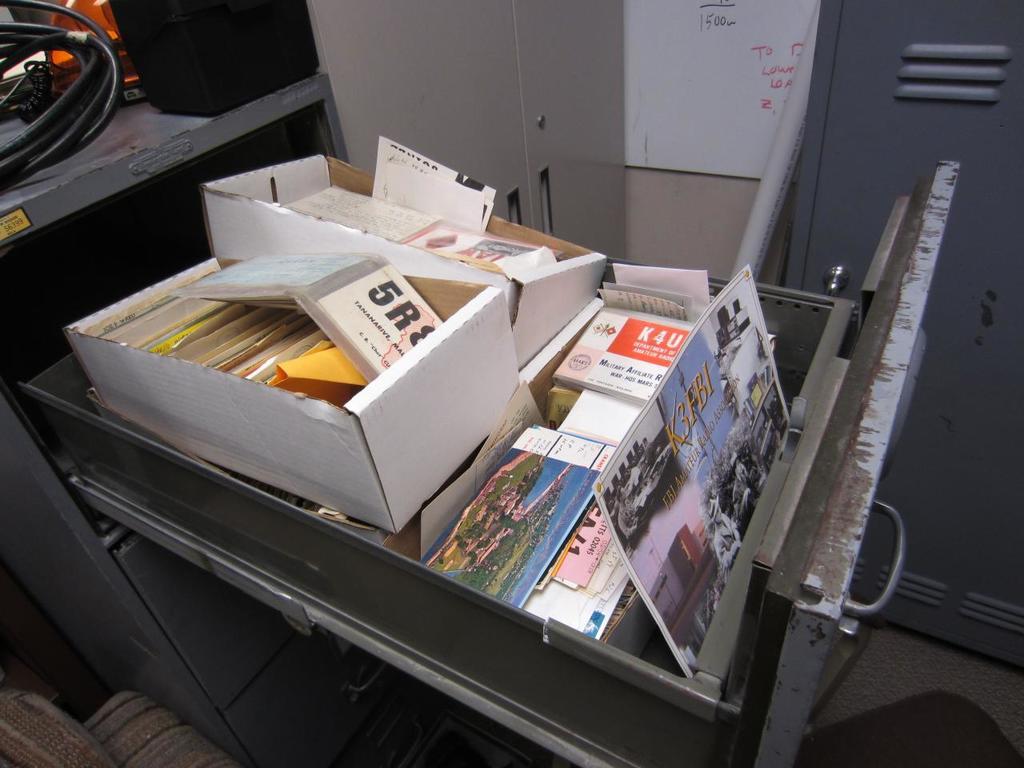What´s the first number on the box?
Provide a succinct answer. 5. 